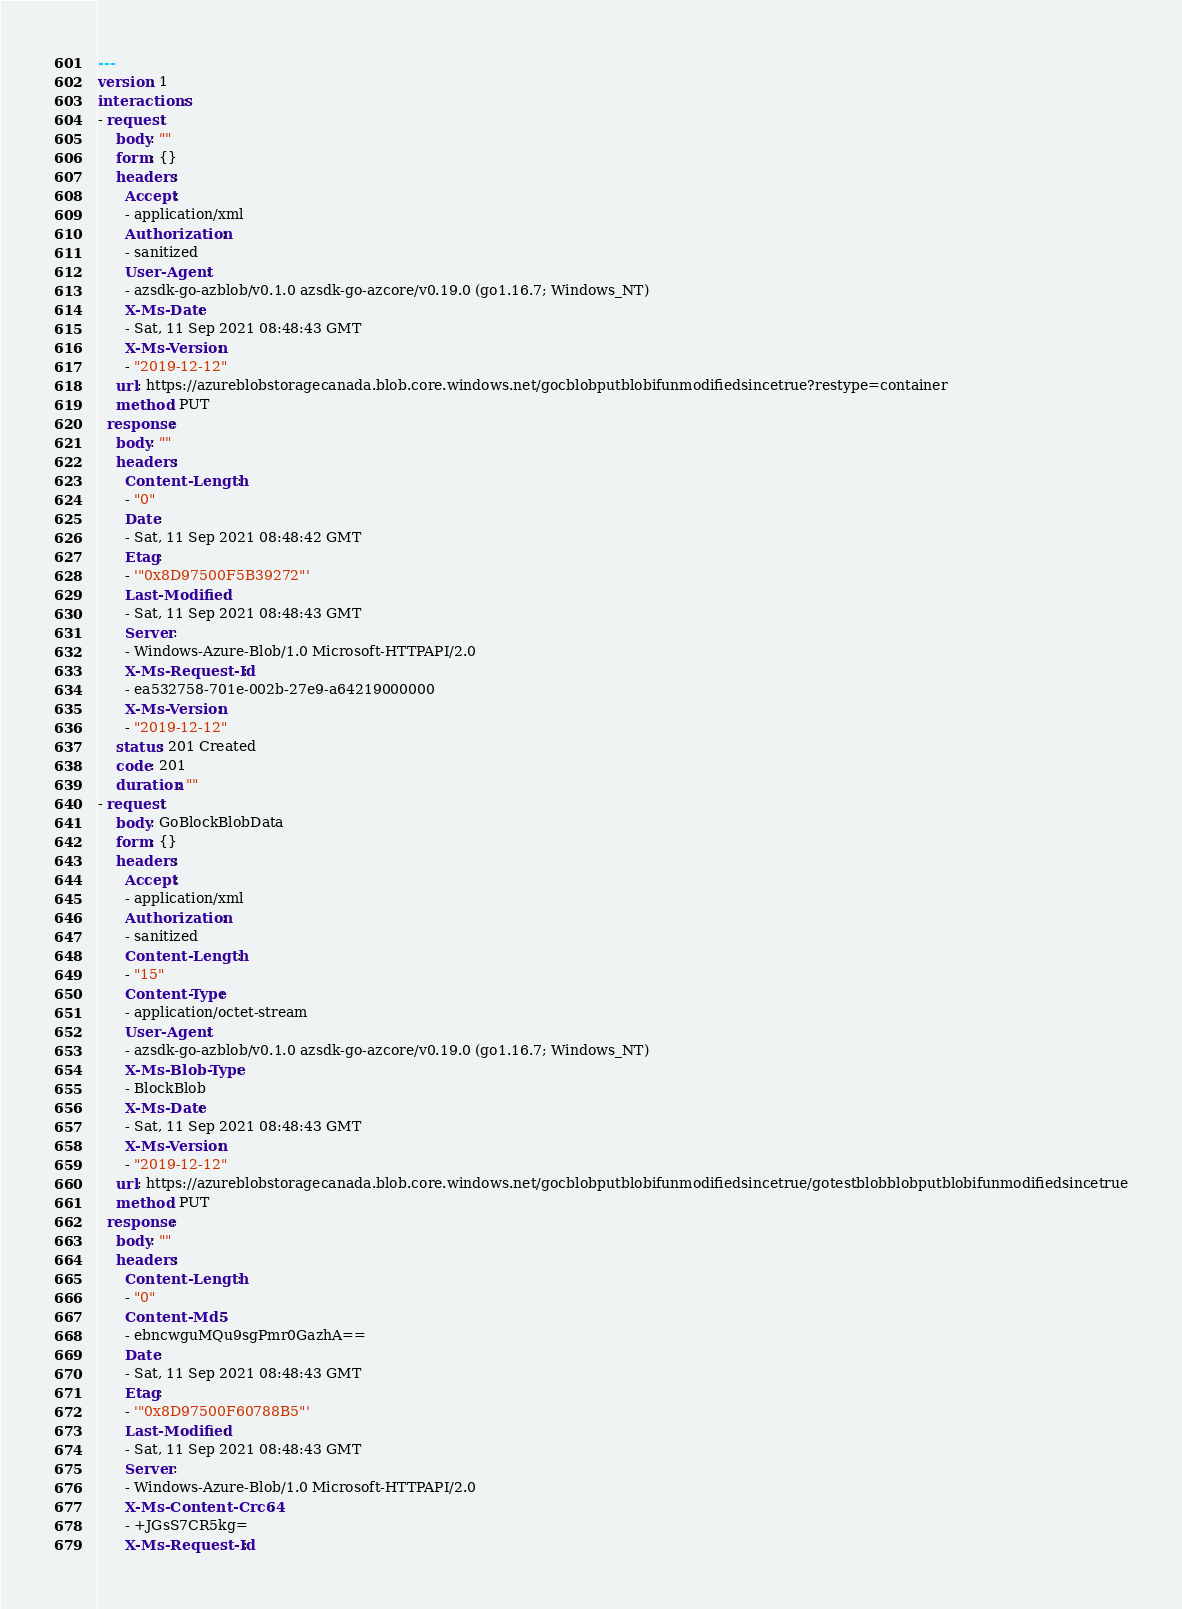<code> <loc_0><loc_0><loc_500><loc_500><_YAML_>---
version: 1
interactions:
- request:
    body: ""
    form: {}
    headers:
      Accept:
      - application/xml
      Authorization:
      - sanitized
      User-Agent:
      - azsdk-go-azblob/v0.1.0 azsdk-go-azcore/v0.19.0 (go1.16.7; Windows_NT)
      X-Ms-Date:
      - Sat, 11 Sep 2021 08:48:43 GMT
      X-Ms-Version:
      - "2019-12-12"
    url: https://azureblobstoragecanada.blob.core.windows.net/gocblobputblobifunmodifiedsincetrue?restype=container
    method: PUT
  response:
    body: ""
    headers:
      Content-Length:
      - "0"
      Date:
      - Sat, 11 Sep 2021 08:48:42 GMT
      Etag:
      - '"0x8D97500F5B39272"'
      Last-Modified:
      - Sat, 11 Sep 2021 08:48:43 GMT
      Server:
      - Windows-Azure-Blob/1.0 Microsoft-HTTPAPI/2.0
      X-Ms-Request-Id:
      - ea532758-701e-002b-27e9-a64219000000
      X-Ms-Version:
      - "2019-12-12"
    status: 201 Created
    code: 201
    duration: ""
- request:
    body: GoBlockBlobData
    form: {}
    headers:
      Accept:
      - application/xml
      Authorization:
      - sanitized
      Content-Length:
      - "15"
      Content-Type:
      - application/octet-stream
      User-Agent:
      - azsdk-go-azblob/v0.1.0 azsdk-go-azcore/v0.19.0 (go1.16.7; Windows_NT)
      X-Ms-Blob-Type:
      - BlockBlob
      X-Ms-Date:
      - Sat, 11 Sep 2021 08:48:43 GMT
      X-Ms-Version:
      - "2019-12-12"
    url: https://azureblobstoragecanada.blob.core.windows.net/gocblobputblobifunmodifiedsincetrue/gotestblobblobputblobifunmodifiedsincetrue
    method: PUT
  response:
    body: ""
    headers:
      Content-Length:
      - "0"
      Content-Md5:
      - ebncwguMQu9sgPmr0GazhA==
      Date:
      - Sat, 11 Sep 2021 08:48:43 GMT
      Etag:
      - '"0x8D97500F60788B5"'
      Last-Modified:
      - Sat, 11 Sep 2021 08:48:43 GMT
      Server:
      - Windows-Azure-Blob/1.0 Microsoft-HTTPAPI/2.0
      X-Ms-Content-Crc64:
      - +JGsS7CR5kg=
      X-Ms-Request-Id:</code> 